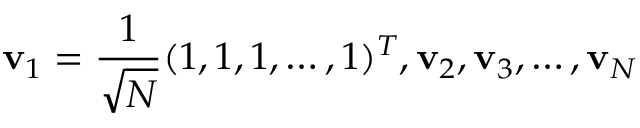<formula> <loc_0><loc_0><loc_500><loc_500>v _ { 1 } = \frac { 1 } { \sqrt { N } } ( 1 , 1 , 1 , \dots , 1 ) ^ { T } , v _ { 2 } , v _ { 3 } , \dots , v _ { N }</formula> 